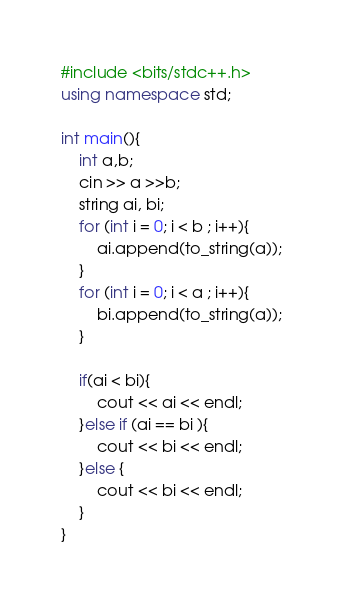Convert code to text. <code><loc_0><loc_0><loc_500><loc_500><_C++_>#include <bits/stdc++.h>
using namespace std;

int main(){
    int a,b;
    cin >> a >>b;
    string ai, bi;
    for (int i = 0; i < b ; i++){
        ai.append(to_string(a));
    }
    for (int i = 0; i < a ; i++){
        bi.append(to_string(a));
    }

    if(ai < bi){
        cout << ai << endl;
    }else if (ai == bi ){
        cout << bi << endl;
    }else {
        cout << bi << endl;
    }
}</code> 